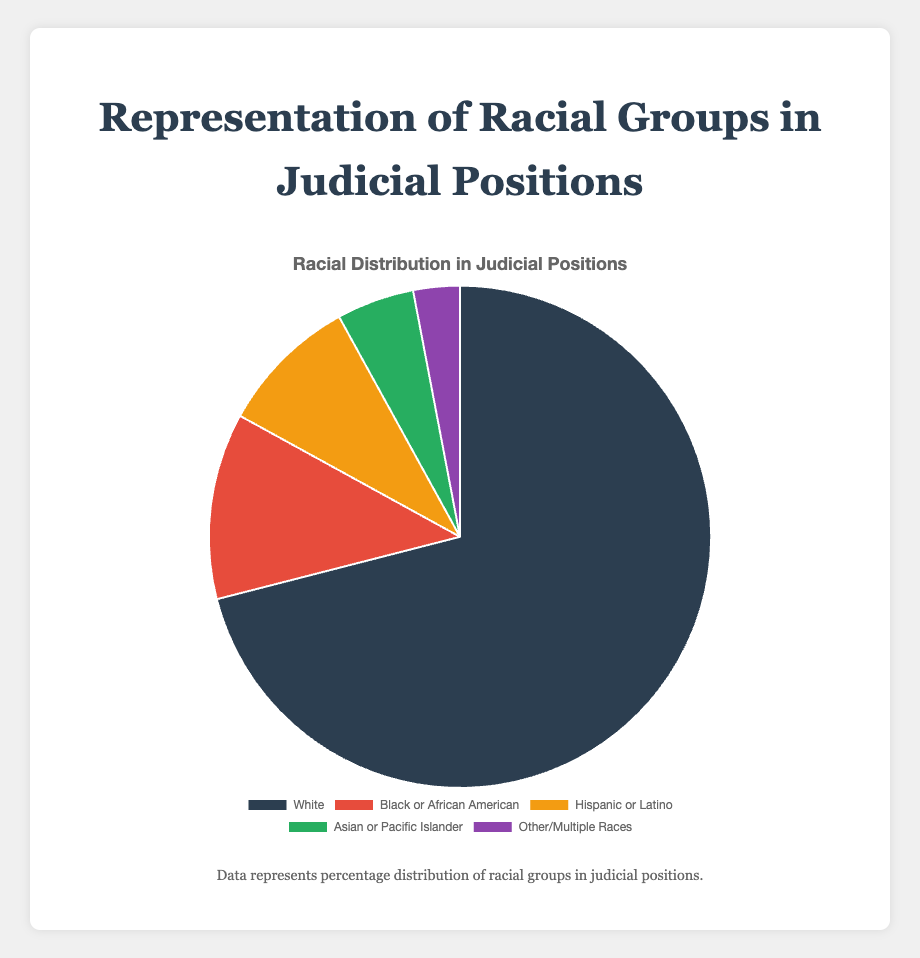What percentage of judicial positions are held by Black or African American individuals? Look at the segment labeled "Black or African American" on the pie chart and refer to its associated percentage.
Answer: 12% Which racial group holds the highest percentage of judicial positions? Identify the largest segment in the pie chart, which represents the racial group with the highest percentage. This can be seen in the segment labeled "White."
Answer: White What is the combined percentage of judicial positions held by Hispanic or Latino and Asian or Pacific Islander individuals? Add the percentages of the two groups: Hispanic or Latino (9%) and Asian or Pacific Islander (5%). 9% + 5% = 14%
Answer: 14% Are there more judicial positions held by Black or African American individuals than Hispanic or Latino individuals? Compare the percentages of the two groups from the pie chart: Black or African American (12%) vs. Hispanic or Latino (9%). 12% is greater than 9%, thus there are more positions held by Black or African American individuals.
Answer: Yes What is the difference in the percentage of judicial positions between White individuals and Other/Multiple Races? Subtract the percentage for Other/Multiple Races (3%) from the percentage for White individuals (71%). 71% - 3% = 68%
Answer: 68% Which groups combined hold less than 10% of the judicial positions? Identify the segments whose percentages add up to less than 10%. The category "Other/Multiple Races" is 3%, which is less than 10% by itself.
Answer: Other/Multiple Races How does the representation of Asian or Pacific Islander individuals compare to that of Hispanic or Latino individuals in judicial positions? Compare the percentages: Asian or Pacific Islander (5%) vs. Hispanic or Latino (9%). The Hispanic or Latino representation is higher.
Answer: Less What visual clue indicates the largest representation in the pie chart? Look for the segment with the largest area/color representation, which corresponds to the highest percentage. In this chart, the "White" segment visually dominates.
Answer: Largest segment What is the total percentage of judicial positions held by all non-White groups combined? Add the percentages of all non-White groups: Black or African American (12%) + Hispanic or Latino (9%) + Asian or Pacific Islander (5%) + Other/Multiple Races (3%). Sum is 12% + 9% + 5% + 3% = 29%
Answer: 29% Does any racial group have a single-digit percentage representation other than Hispanic or Latino? Review the percentages; look for other segments with a single-digit value besides Hispanic or Latino (9%). Asian or Pacific Islander (5%) and Other/Multiple Races (3%) also fall into this category.
Answer: Yes 